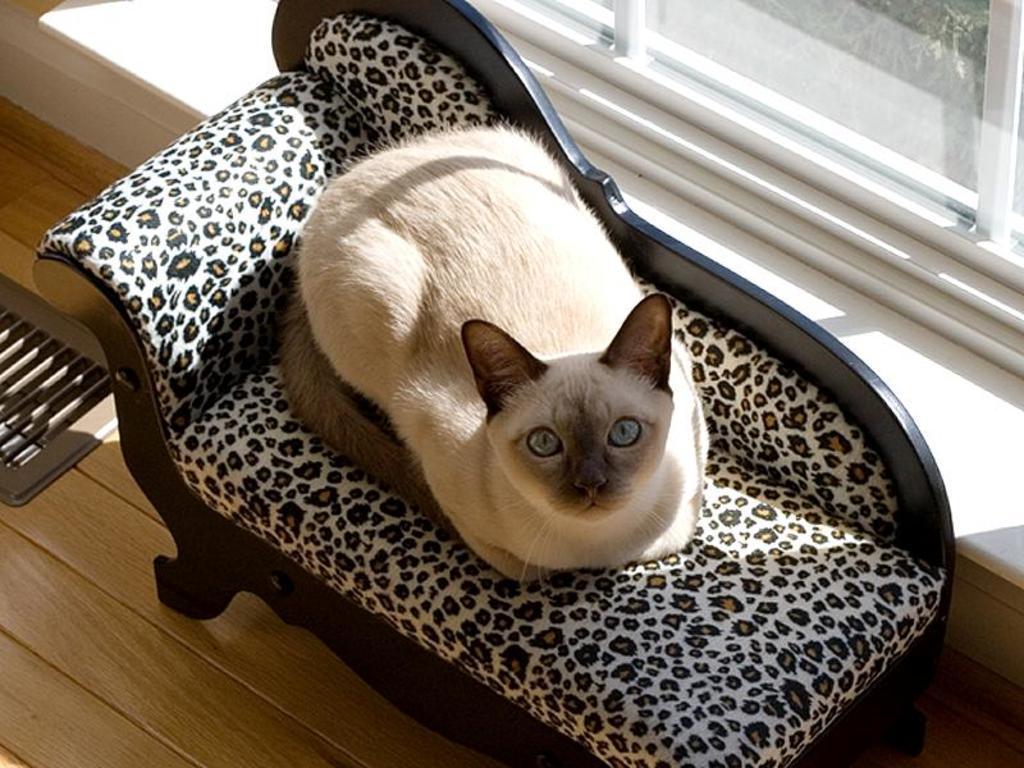What animal can be seen in the image? There is a cat in the image. Where is the cat located? The cat is on a couch. What type of flooring is visible in the image? There is a wooden floor in the image. What type of window is present in the image? There is a glass window in the image. Where is the glass window located in relation to the couch? The glass window is behind the couch. What type of pleasure can be seen in the field in the image? There is no field or pleasure present in the image; it features a cat on a couch with a wooden floor and a glass window. Are there any dinosaurs visible in the image? No, there are no dinosaurs present in the image. 